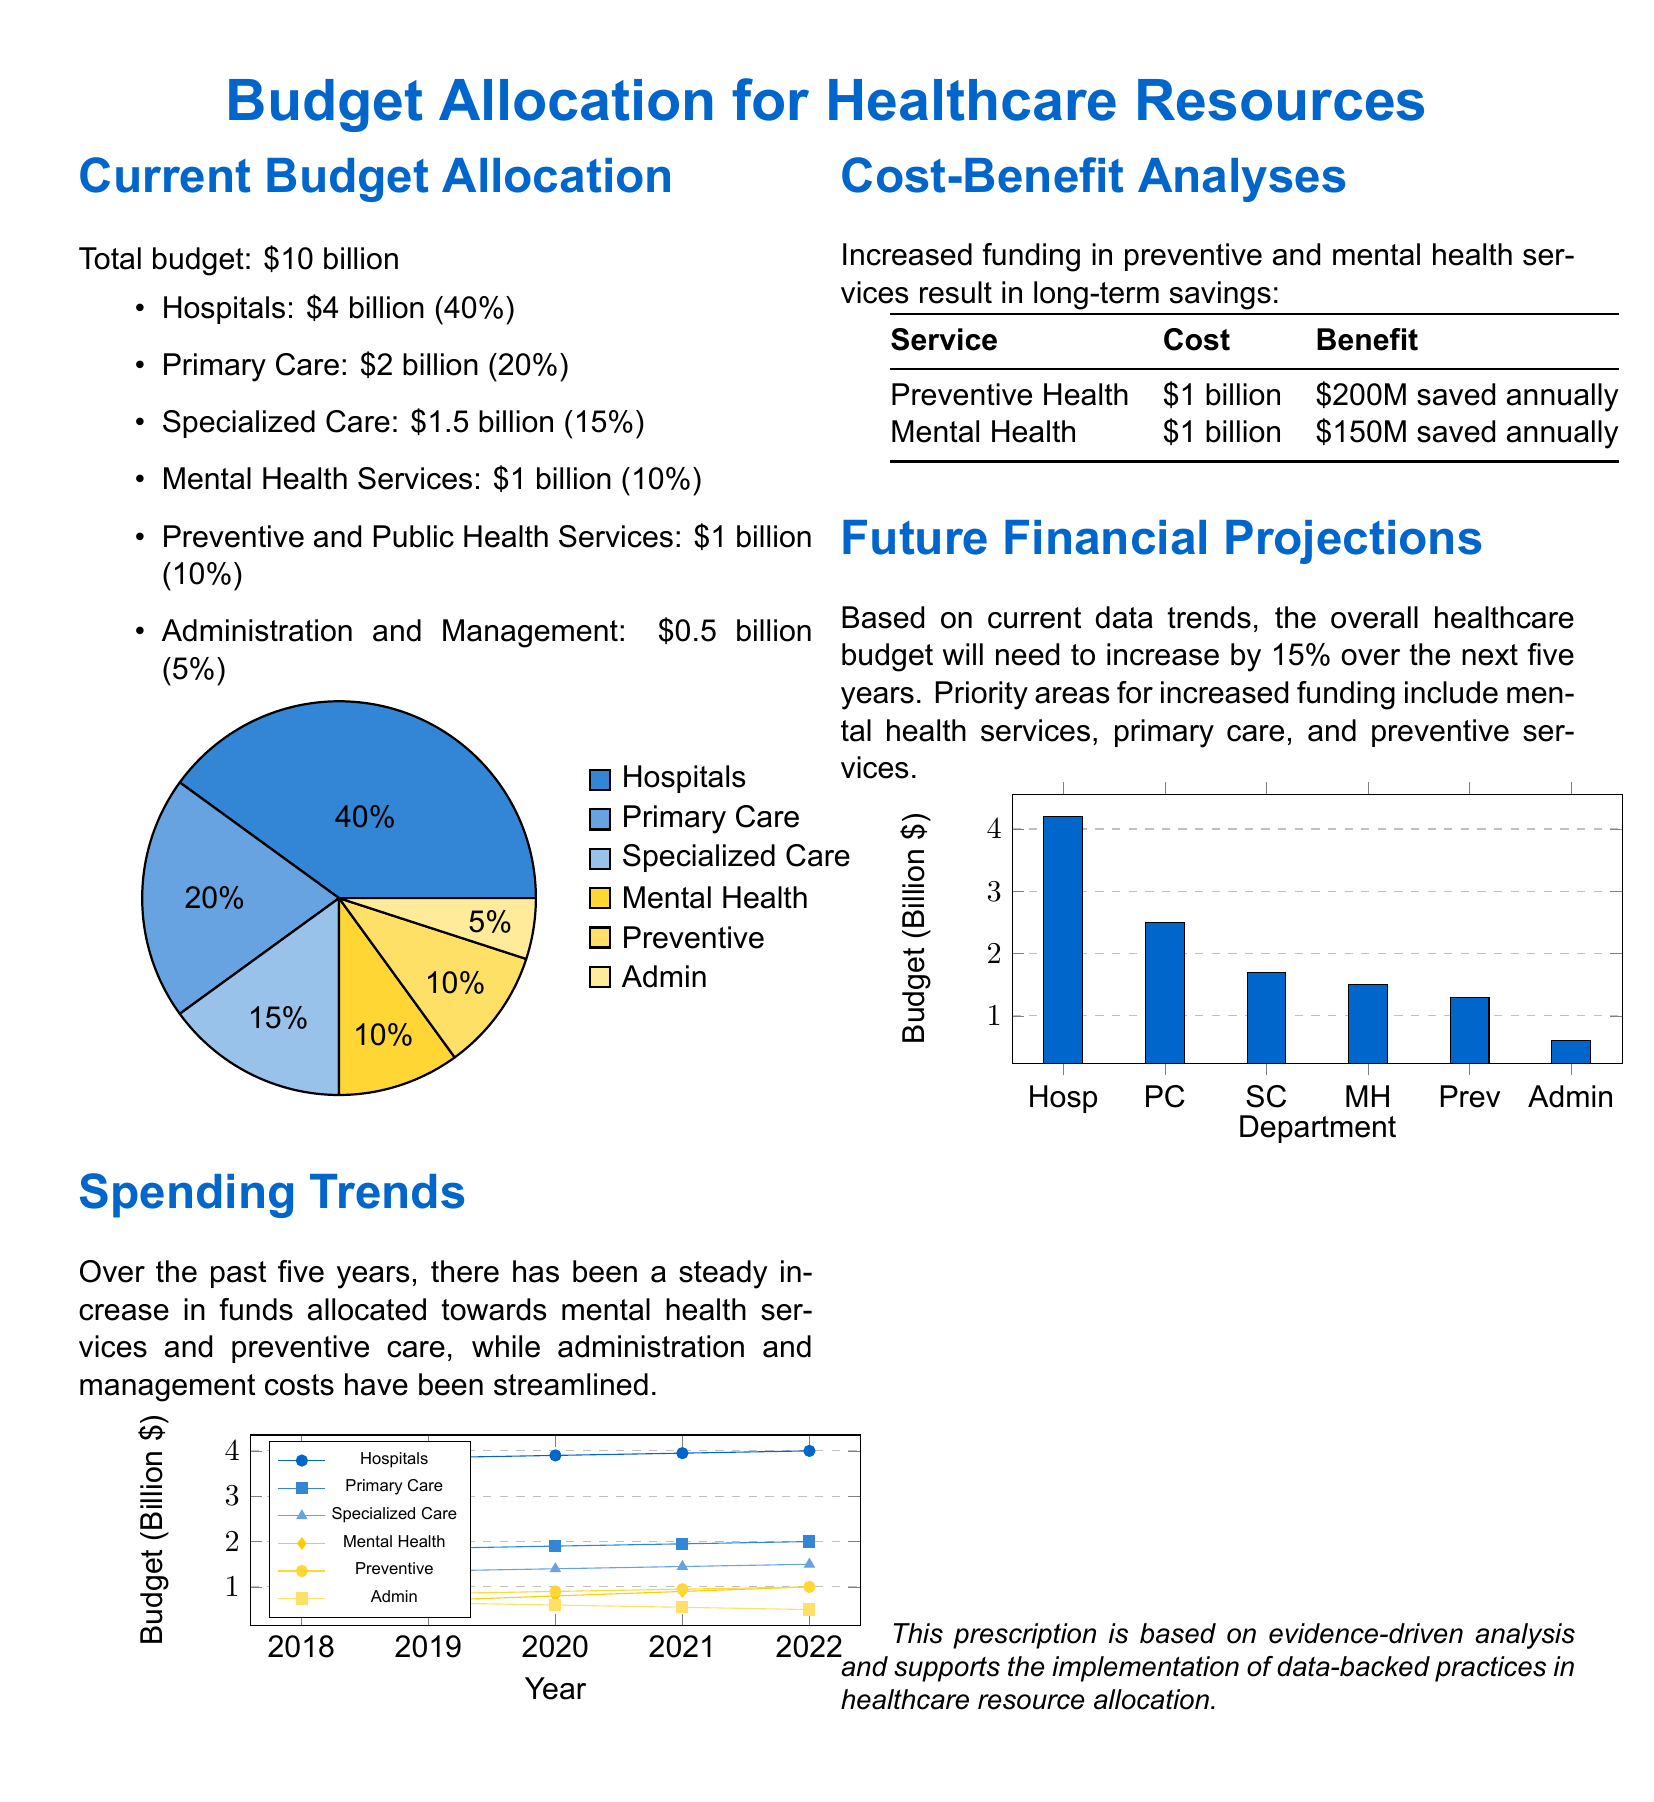What is the total budget? The total budget is explicitly stated in the document as $10 billion.
Answer: $10 billion How much is allocated to Mental Health Services? The allocation for Mental Health Services can be found in the Current Budget Allocation section, which states $1 billion.
Answer: $1 billion What percentage of the budget is designated for Specialized Care? The document indicates that Specialized Care receives 15% of the total budget.
Answer: 15% Which department has seen a steady increase in funding over the past five years? The Spending Trends section discusses a steady increase in funds toward mental health services, indicating its significant growth.
Answer: Mental Health Services What is the projected increase in the overall healthcare budget over the next five years? The Future Financial Projections section mentions a 15% increase projected for the overall healthcare budget.
Answer: 15% How much does Preventive Health cost versus its annual savings? The Cost-Benefit Analyses table shows that Preventive Health costs $1 billion and saves $200 million annually.
Answer: $1 billion and $200 million Which department had the lowest allocation according to the Current Budget Allocation? According to the document, Administration and Management has the lowest allocation of $0.5 billion.
Answer: $0.5 billion What trend is observed in the Administration and Management allocation over five years? The document notes that administration and management costs have been streamlined, indicating a reduction in funding.
Answer: Streamlined In which areas is priority funding expected to increase? The Future Financial Projections mention increased funding priorities for mental health services, primary care, and preventive services.
Answer: Mental health services, primary care, and preventive services 